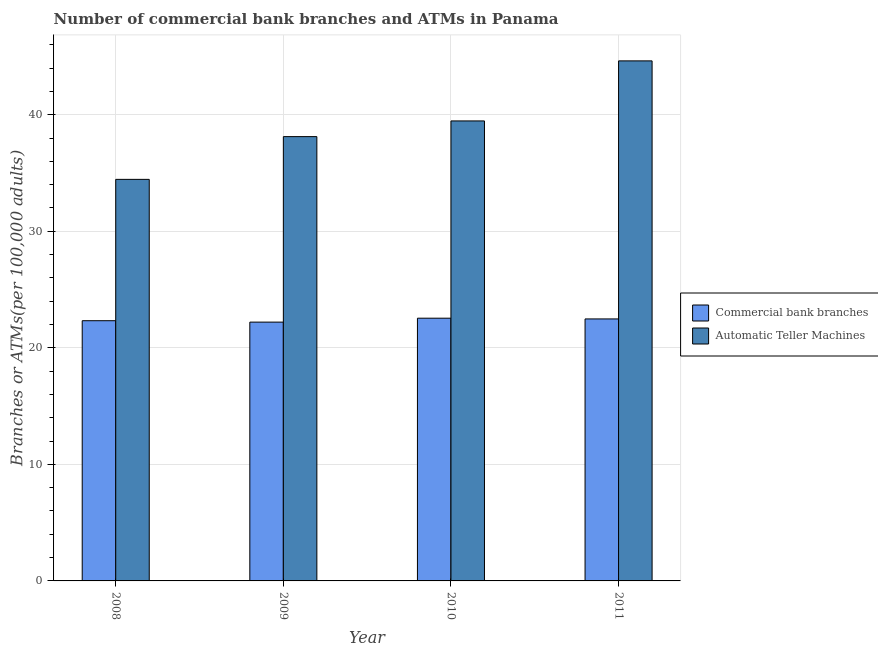How many different coloured bars are there?
Offer a terse response. 2. How many groups of bars are there?
Offer a terse response. 4. Are the number of bars per tick equal to the number of legend labels?
Ensure brevity in your answer.  Yes. Are the number of bars on each tick of the X-axis equal?
Your answer should be compact. Yes. How many bars are there on the 1st tick from the left?
Your response must be concise. 2. How many bars are there on the 1st tick from the right?
Give a very brief answer. 2. What is the label of the 3rd group of bars from the left?
Ensure brevity in your answer.  2010. What is the number of commercal bank branches in 2008?
Your response must be concise. 22.33. Across all years, what is the maximum number of commercal bank branches?
Your answer should be compact. 22.54. Across all years, what is the minimum number of atms?
Your response must be concise. 34.45. What is the total number of atms in the graph?
Offer a terse response. 156.65. What is the difference between the number of commercal bank branches in 2008 and that in 2011?
Offer a very short reply. -0.15. What is the difference between the number of atms in 2008 and the number of commercal bank branches in 2010?
Ensure brevity in your answer.  -5.01. What is the average number of atms per year?
Offer a terse response. 39.16. What is the ratio of the number of atms in 2008 to that in 2010?
Provide a succinct answer. 0.87. Is the difference between the number of atms in 2010 and 2011 greater than the difference between the number of commercal bank branches in 2010 and 2011?
Make the answer very short. No. What is the difference between the highest and the second highest number of commercal bank branches?
Ensure brevity in your answer.  0.06. What is the difference between the highest and the lowest number of atms?
Provide a succinct answer. 10.17. Is the sum of the number of commercal bank branches in 2009 and 2010 greater than the maximum number of atms across all years?
Offer a terse response. Yes. What does the 2nd bar from the left in 2009 represents?
Offer a very short reply. Automatic Teller Machines. What does the 2nd bar from the right in 2010 represents?
Your answer should be very brief. Commercial bank branches. Are all the bars in the graph horizontal?
Provide a short and direct response. No. How many years are there in the graph?
Your response must be concise. 4. What is the difference between two consecutive major ticks on the Y-axis?
Provide a short and direct response. 10. Are the values on the major ticks of Y-axis written in scientific E-notation?
Offer a very short reply. No. Does the graph contain any zero values?
Keep it short and to the point. No. How are the legend labels stacked?
Your response must be concise. Vertical. What is the title of the graph?
Ensure brevity in your answer.  Number of commercial bank branches and ATMs in Panama. Does "Diarrhea" appear as one of the legend labels in the graph?
Your answer should be compact. No. What is the label or title of the X-axis?
Your response must be concise. Year. What is the label or title of the Y-axis?
Give a very brief answer. Branches or ATMs(per 100,0 adults). What is the Branches or ATMs(per 100,000 adults) in Commercial bank branches in 2008?
Give a very brief answer. 22.33. What is the Branches or ATMs(per 100,000 adults) of Automatic Teller Machines in 2008?
Keep it short and to the point. 34.45. What is the Branches or ATMs(per 100,000 adults) of Commercial bank branches in 2009?
Ensure brevity in your answer.  22.2. What is the Branches or ATMs(per 100,000 adults) in Automatic Teller Machines in 2009?
Keep it short and to the point. 38.12. What is the Branches or ATMs(per 100,000 adults) of Commercial bank branches in 2010?
Offer a terse response. 22.54. What is the Branches or ATMs(per 100,000 adults) of Automatic Teller Machines in 2010?
Offer a terse response. 39.46. What is the Branches or ATMs(per 100,000 adults) in Commercial bank branches in 2011?
Offer a terse response. 22.48. What is the Branches or ATMs(per 100,000 adults) in Automatic Teller Machines in 2011?
Your answer should be very brief. 44.62. Across all years, what is the maximum Branches or ATMs(per 100,000 adults) in Commercial bank branches?
Ensure brevity in your answer.  22.54. Across all years, what is the maximum Branches or ATMs(per 100,000 adults) in Automatic Teller Machines?
Ensure brevity in your answer.  44.62. Across all years, what is the minimum Branches or ATMs(per 100,000 adults) of Commercial bank branches?
Your answer should be very brief. 22.2. Across all years, what is the minimum Branches or ATMs(per 100,000 adults) in Automatic Teller Machines?
Provide a short and direct response. 34.45. What is the total Branches or ATMs(per 100,000 adults) of Commercial bank branches in the graph?
Your response must be concise. 89.55. What is the total Branches or ATMs(per 100,000 adults) of Automatic Teller Machines in the graph?
Offer a terse response. 156.65. What is the difference between the Branches or ATMs(per 100,000 adults) in Commercial bank branches in 2008 and that in 2009?
Your answer should be very brief. 0.12. What is the difference between the Branches or ATMs(per 100,000 adults) of Automatic Teller Machines in 2008 and that in 2009?
Offer a very short reply. -3.67. What is the difference between the Branches or ATMs(per 100,000 adults) of Commercial bank branches in 2008 and that in 2010?
Offer a very short reply. -0.21. What is the difference between the Branches or ATMs(per 100,000 adults) of Automatic Teller Machines in 2008 and that in 2010?
Your answer should be compact. -5.01. What is the difference between the Branches or ATMs(per 100,000 adults) of Commercial bank branches in 2008 and that in 2011?
Provide a short and direct response. -0.15. What is the difference between the Branches or ATMs(per 100,000 adults) in Automatic Teller Machines in 2008 and that in 2011?
Provide a succinct answer. -10.17. What is the difference between the Branches or ATMs(per 100,000 adults) in Commercial bank branches in 2009 and that in 2010?
Your answer should be very brief. -0.34. What is the difference between the Branches or ATMs(per 100,000 adults) of Automatic Teller Machines in 2009 and that in 2010?
Make the answer very short. -1.35. What is the difference between the Branches or ATMs(per 100,000 adults) in Commercial bank branches in 2009 and that in 2011?
Your answer should be compact. -0.27. What is the difference between the Branches or ATMs(per 100,000 adults) of Automatic Teller Machines in 2009 and that in 2011?
Provide a succinct answer. -6.5. What is the difference between the Branches or ATMs(per 100,000 adults) of Commercial bank branches in 2010 and that in 2011?
Give a very brief answer. 0.06. What is the difference between the Branches or ATMs(per 100,000 adults) of Automatic Teller Machines in 2010 and that in 2011?
Offer a terse response. -5.15. What is the difference between the Branches or ATMs(per 100,000 adults) of Commercial bank branches in 2008 and the Branches or ATMs(per 100,000 adults) of Automatic Teller Machines in 2009?
Give a very brief answer. -15.79. What is the difference between the Branches or ATMs(per 100,000 adults) of Commercial bank branches in 2008 and the Branches or ATMs(per 100,000 adults) of Automatic Teller Machines in 2010?
Keep it short and to the point. -17.14. What is the difference between the Branches or ATMs(per 100,000 adults) of Commercial bank branches in 2008 and the Branches or ATMs(per 100,000 adults) of Automatic Teller Machines in 2011?
Ensure brevity in your answer.  -22.29. What is the difference between the Branches or ATMs(per 100,000 adults) in Commercial bank branches in 2009 and the Branches or ATMs(per 100,000 adults) in Automatic Teller Machines in 2010?
Keep it short and to the point. -17.26. What is the difference between the Branches or ATMs(per 100,000 adults) of Commercial bank branches in 2009 and the Branches or ATMs(per 100,000 adults) of Automatic Teller Machines in 2011?
Your response must be concise. -22.41. What is the difference between the Branches or ATMs(per 100,000 adults) in Commercial bank branches in 2010 and the Branches or ATMs(per 100,000 adults) in Automatic Teller Machines in 2011?
Provide a short and direct response. -22.08. What is the average Branches or ATMs(per 100,000 adults) in Commercial bank branches per year?
Offer a terse response. 22.39. What is the average Branches or ATMs(per 100,000 adults) of Automatic Teller Machines per year?
Offer a terse response. 39.16. In the year 2008, what is the difference between the Branches or ATMs(per 100,000 adults) of Commercial bank branches and Branches or ATMs(per 100,000 adults) of Automatic Teller Machines?
Provide a short and direct response. -12.13. In the year 2009, what is the difference between the Branches or ATMs(per 100,000 adults) in Commercial bank branches and Branches or ATMs(per 100,000 adults) in Automatic Teller Machines?
Provide a short and direct response. -15.92. In the year 2010, what is the difference between the Branches or ATMs(per 100,000 adults) of Commercial bank branches and Branches or ATMs(per 100,000 adults) of Automatic Teller Machines?
Keep it short and to the point. -16.92. In the year 2011, what is the difference between the Branches or ATMs(per 100,000 adults) of Commercial bank branches and Branches or ATMs(per 100,000 adults) of Automatic Teller Machines?
Your response must be concise. -22.14. What is the ratio of the Branches or ATMs(per 100,000 adults) of Automatic Teller Machines in 2008 to that in 2009?
Make the answer very short. 0.9. What is the ratio of the Branches or ATMs(per 100,000 adults) of Commercial bank branches in 2008 to that in 2010?
Provide a succinct answer. 0.99. What is the ratio of the Branches or ATMs(per 100,000 adults) in Automatic Teller Machines in 2008 to that in 2010?
Keep it short and to the point. 0.87. What is the ratio of the Branches or ATMs(per 100,000 adults) of Automatic Teller Machines in 2008 to that in 2011?
Your answer should be very brief. 0.77. What is the ratio of the Branches or ATMs(per 100,000 adults) in Commercial bank branches in 2009 to that in 2010?
Your answer should be compact. 0.99. What is the ratio of the Branches or ATMs(per 100,000 adults) of Automatic Teller Machines in 2009 to that in 2010?
Make the answer very short. 0.97. What is the ratio of the Branches or ATMs(per 100,000 adults) in Automatic Teller Machines in 2009 to that in 2011?
Your response must be concise. 0.85. What is the ratio of the Branches or ATMs(per 100,000 adults) of Commercial bank branches in 2010 to that in 2011?
Offer a very short reply. 1. What is the ratio of the Branches or ATMs(per 100,000 adults) of Automatic Teller Machines in 2010 to that in 2011?
Make the answer very short. 0.88. What is the difference between the highest and the second highest Branches or ATMs(per 100,000 adults) of Commercial bank branches?
Offer a terse response. 0.06. What is the difference between the highest and the second highest Branches or ATMs(per 100,000 adults) in Automatic Teller Machines?
Keep it short and to the point. 5.15. What is the difference between the highest and the lowest Branches or ATMs(per 100,000 adults) in Commercial bank branches?
Your answer should be very brief. 0.34. What is the difference between the highest and the lowest Branches or ATMs(per 100,000 adults) in Automatic Teller Machines?
Offer a terse response. 10.17. 